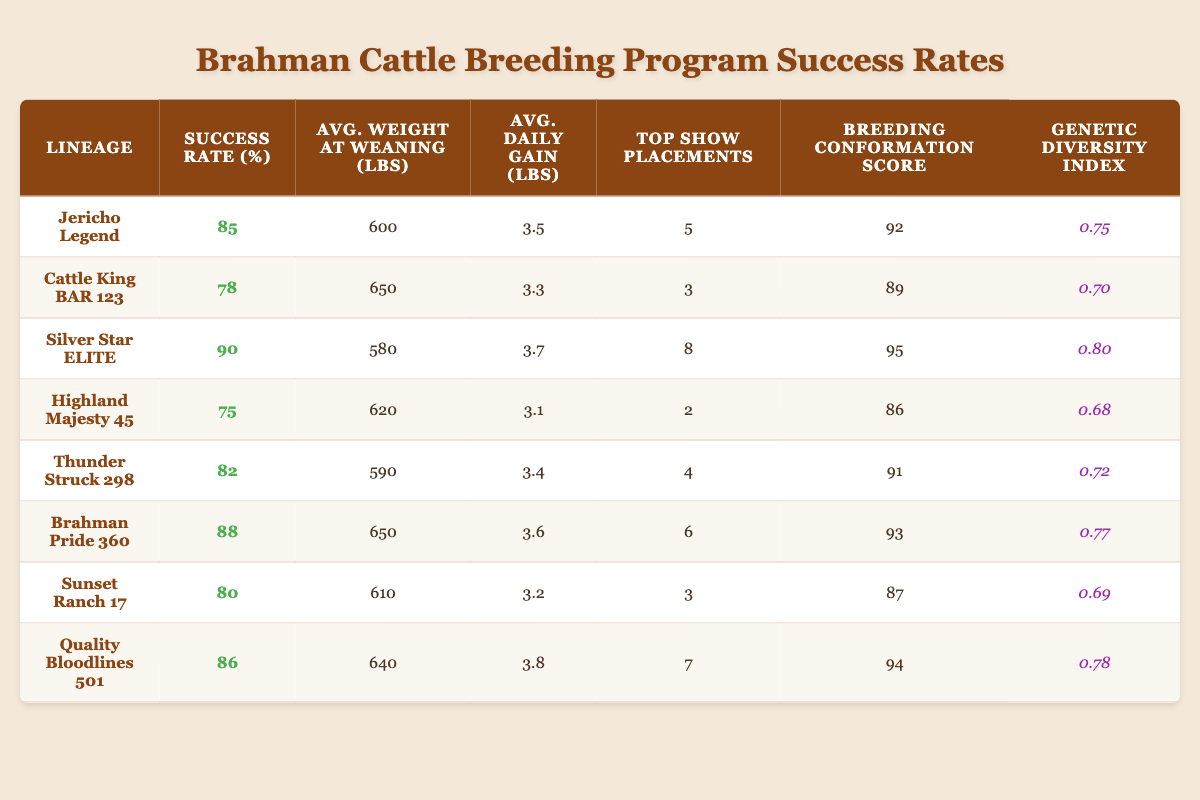What is the success rate of the Silver Star ELITE lineage? The table clearly states that the success rate of the Silver Star ELITE lineage is listed directly in the corresponding row under the "Success Rate (%)" column.
Answer: 90 Which lineage has the highest average weight at weaning? By comparing all the entries in the "Avg. Weight at Weaning (lbs)" column, it can be seen that Cattle King BAR 123 has the highest value at 650 lbs.
Answer: Cattle King BAR 123 How many top show placements did Brahman Pride 360 achieve? From the table, the "Top Show Placements" column indicates that Brahman Pride 360 achieved 6 placements.
Answer: 6 What is the average daily gain for Jericho Legend? Looking at the table under the "Avg. Daily Gain (lbs)" column, Jericho Legend is reported to have an average daily gain of 3.5 lbs.
Answer: 3.5 Which lineage has a breeding conformation score higher than 90? A review of the "Breeding Conformation Score" column reveals that Silver Star ELITE (95), Brahman Pride 360 (93), and Quality Bloodlines 501 (94) all have scores above 90.
Answer: Silver Star ELITE, Brahman Pride 360, Quality Bloodlines 501 What is the average success rate for lineages with a genetic diversity index above 0.75? The lineages with a genetic diversity index above 0.75 are Jericho Legend (85), Silver Star ELITE (90), Brahman Pride 360 (88), Quality Bloodlines 501 (86). The average is calculated as (85 + 90 + 88 + 86) / 4 = 87.25.
Answer: 87.25 Is there a lineage that has both a top show placement and a success rate of 75% or less? Checking the table for any entries with a success rate of 75% or less, only Highland Majesty 45 (75%) has 2 top show placements. Therefore, the answer is yes.
Answer: Yes If the average daily gain of each lineage was summed, what is the total? By summing the "Avg. Daily Gain (lbs)" across all entries (3.5 + 3.3 + 3.7 + 3.1 + 3.4 + 3.6 + 3.2 + 3.8), you get a total of 25.6 lbs.
Answer: 25.6 Which lineage has the lowest genetic diversity index? The lowest value in the "Genetic Diversity Index" column is 0.68, which corresponds to Highland Majesty 45.
Answer: Highland Majesty 45 How many lineages have a success rate greater than 80%? By counting the entries in the "Success Rate (%)" column that are above 80% (Jericho Legend, Silver Star ELITE, Brahman Pride 360, Quality Bloodlines 501), we find there are 4 lineages meeting this criterion.
Answer: 4 What is the difference in success rates between Silver Star ELITE and Highland Majesty 45? The success rate for Silver Star ELITE is 90, and for Highland Majesty 45 it is 75. The difference is calculated as 90 - 75 = 15.
Answer: 15 